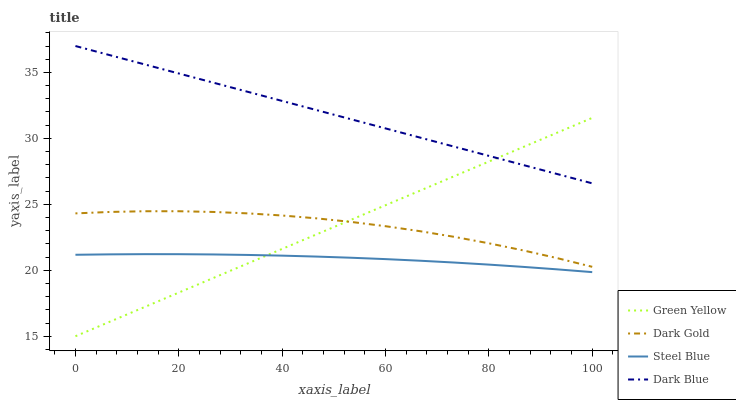Does Steel Blue have the minimum area under the curve?
Answer yes or no. Yes. Does Dark Blue have the maximum area under the curve?
Answer yes or no. Yes. Does Green Yellow have the minimum area under the curve?
Answer yes or no. No. Does Green Yellow have the maximum area under the curve?
Answer yes or no. No. Is Green Yellow the smoothest?
Answer yes or no. Yes. Is Dark Gold the roughest?
Answer yes or no. Yes. Is Steel Blue the smoothest?
Answer yes or no. No. Is Steel Blue the roughest?
Answer yes or no. No. Does Green Yellow have the lowest value?
Answer yes or no. Yes. Does Steel Blue have the lowest value?
Answer yes or no. No. Does Dark Blue have the highest value?
Answer yes or no. Yes. Does Green Yellow have the highest value?
Answer yes or no. No. Is Steel Blue less than Dark Gold?
Answer yes or no. Yes. Is Dark Blue greater than Steel Blue?
Answer yes or no. Yes. Does Green Yellow intersect Steel Blue?
Answer yes or no. Yes. Is Green Yellow less than Steel Blue?
Answer yes or no. No. Is Green Yellow greater than Steel Blue?
Answer yes or no. No. Does Steel Blue intersect Dark Gold?
Answer yes or no. No. 